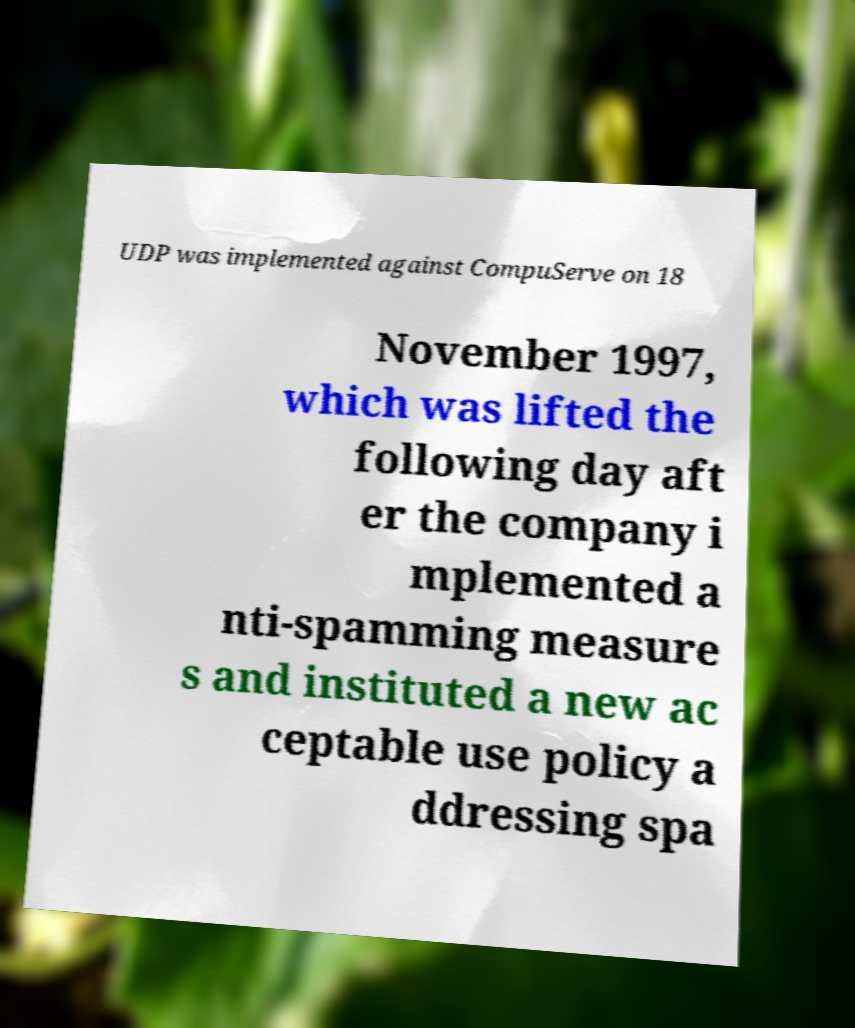Could you assist in decoding the text presented in this image and type it out clearly? UDP was implemented against CompuServe on 18 November 1997, which was lifted the following day aft er the company i mplemented a nti-spamming measure s and instituted a new ac ceptable use policy a ddressing spa 